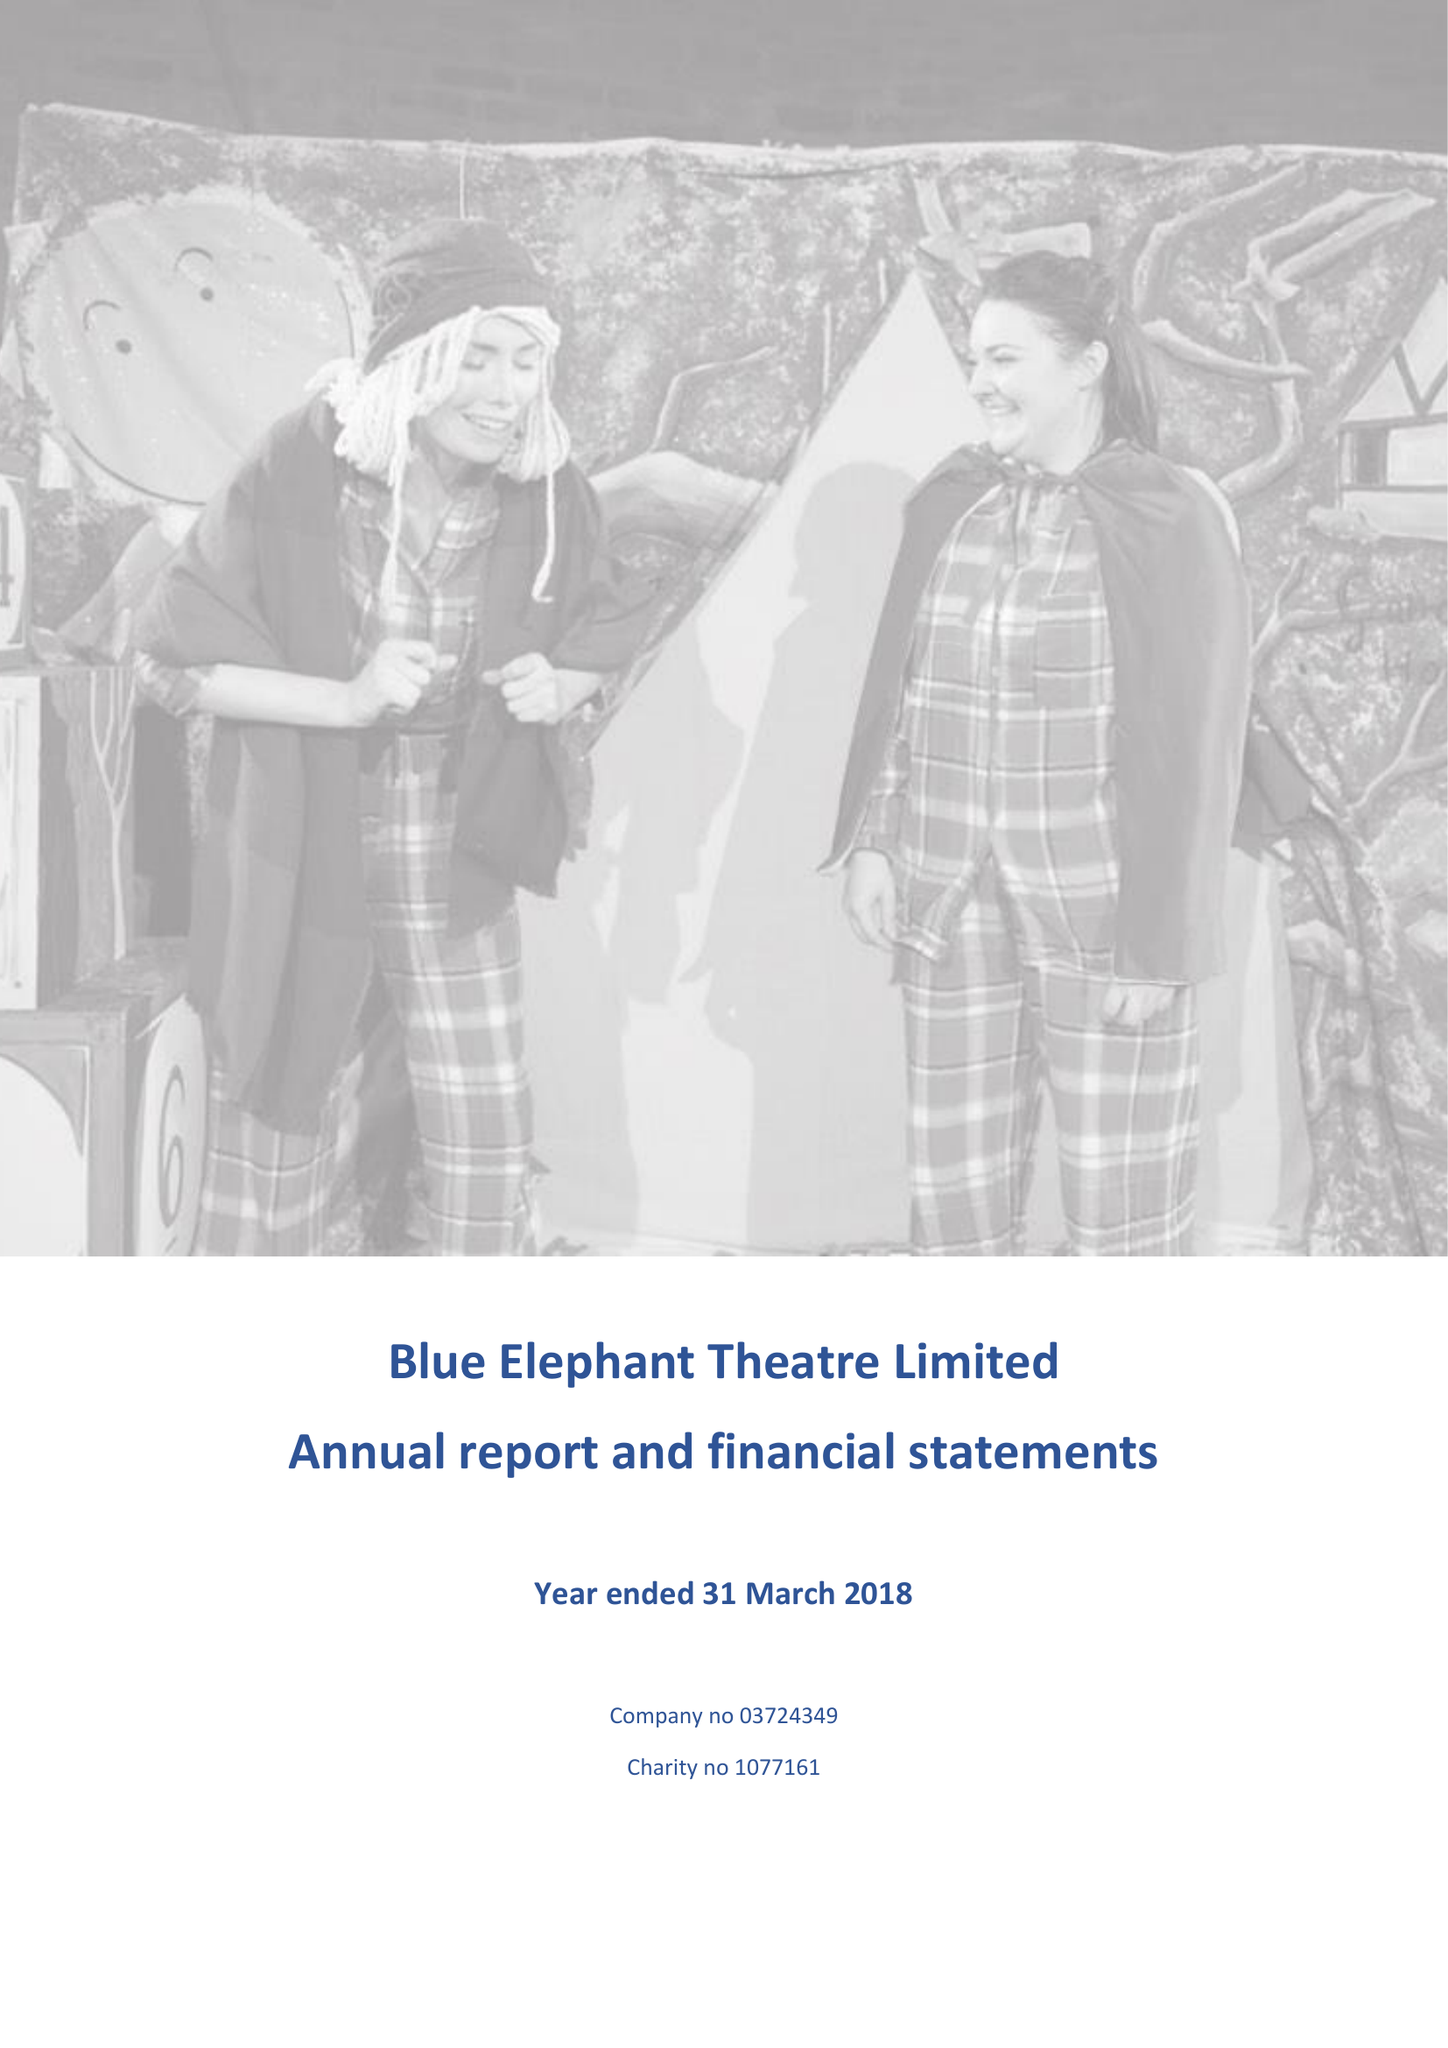What is the value for the report_date?
Answer the question using a single word or phrase. 2018-03-31 